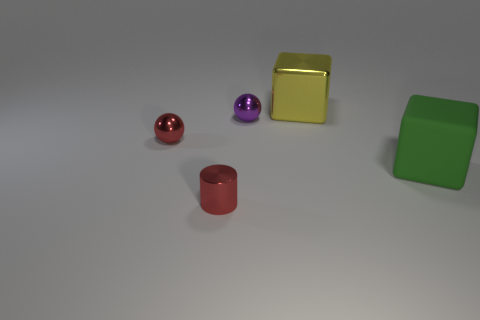Add 1 blocks. How many objects exist? 6 Subtract all cylinders. How many objects are left? 4 Add 3 large matte blocks. How many large matte blocks exist? 4 Subtract 0 gray blocks. How many objects are left? 5 Subtract all red things. Subtract all small red metallic objects. How many objects are left? 1 Add 4 big yellow metal cubes. How many big yellow metal cubes are left? 5 